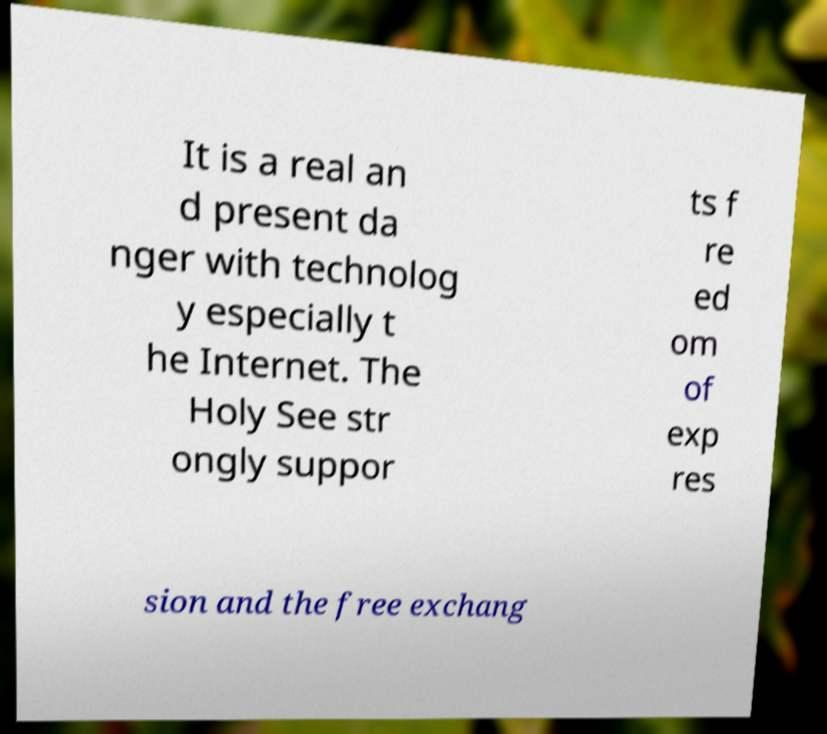Could you extract and type out the text from this image? It is a real an d present da nger with technolog y especially t he Internet. The Holy See str ongly suppor ts f re ed om of exp res sion and the free exchang 